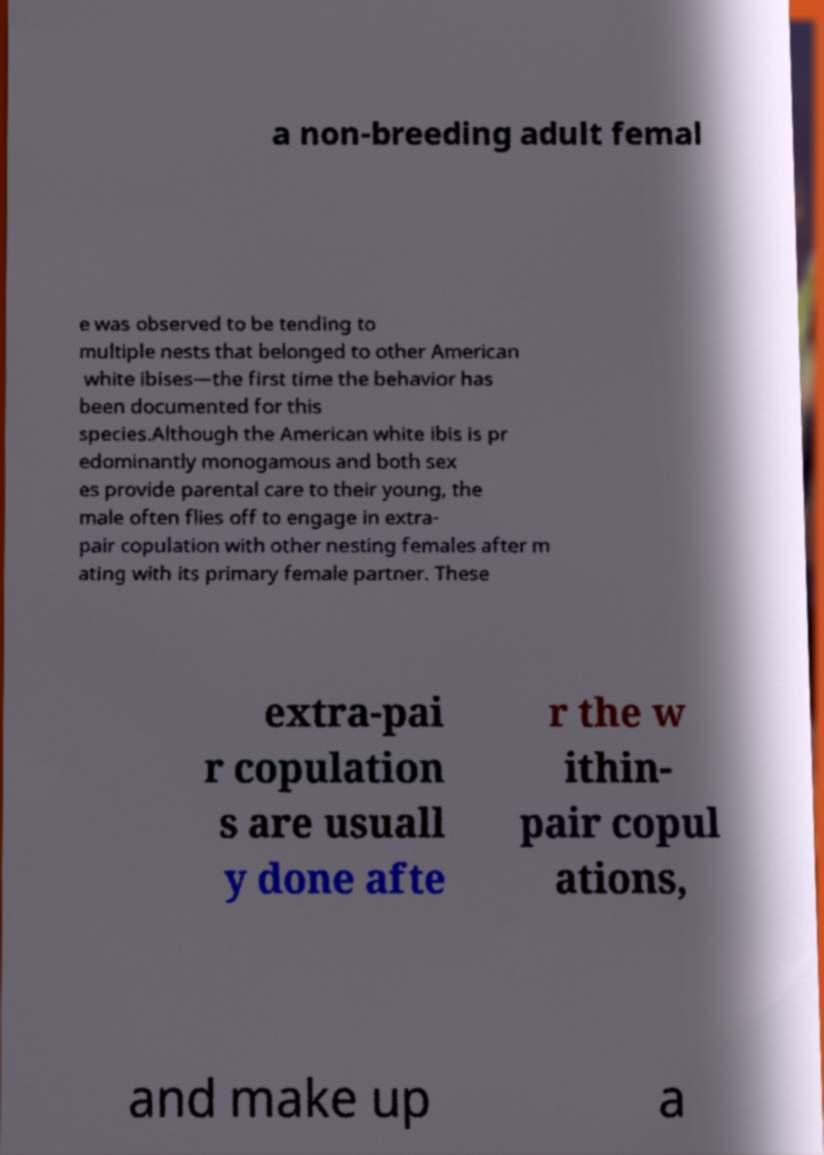There's text embedded in this image that I need extracted. Can you transcribe it verbatim? a non-breeding adult femal e was observed to be tending to multiple nests that belonged to other American white ibises—the first time the behavior has been documented for this species.Although the American white ibis is pr edominantly monogamous and both sex es provide parental care to their young, the male often flies off to engage in extra- pair copulation with other nesting females after m ating with its primary female partner. These extra-pai r copulation s are usuall y done afte r the w ithin- pair copul ations, and make up a 